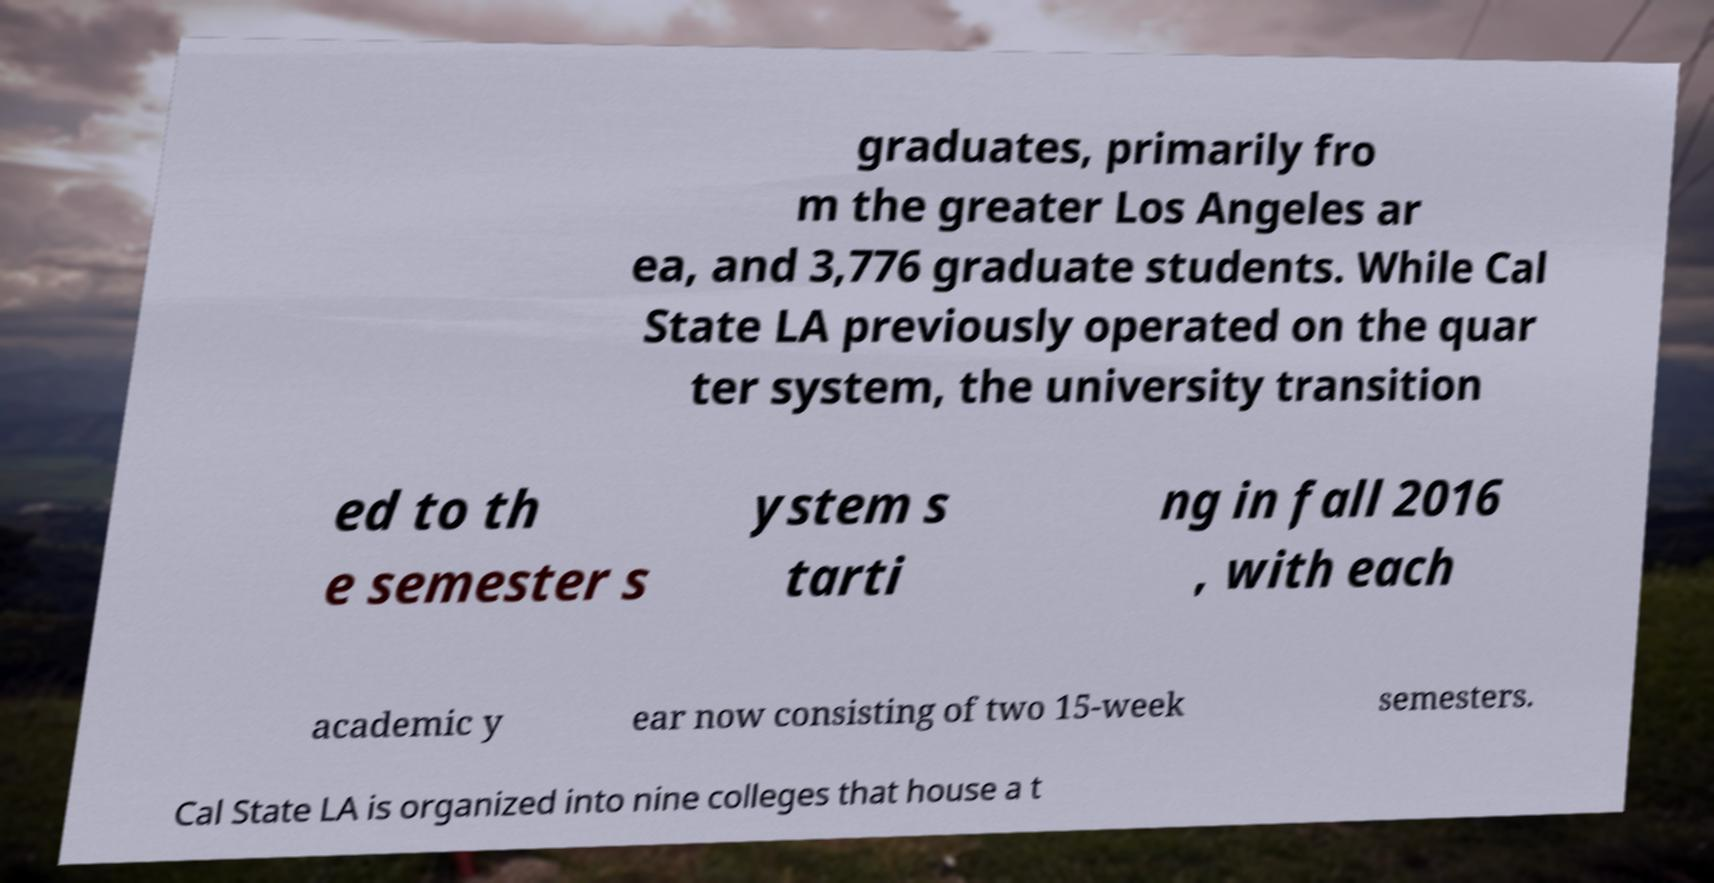What messages or text are displayed in this image? I need them in a readable, typed format. graduates, primarily fro m the greater Los Angeles ar ea, and 3,776 graduate students. While Cal State LA previously operated on the quar ter system, the university transition ed to th e semester s ystem s tarti ng in fall 2016 , with each academic y ear now consisting of two 15-week semesters. Cal State LA is organized into nine colleges that house a t 